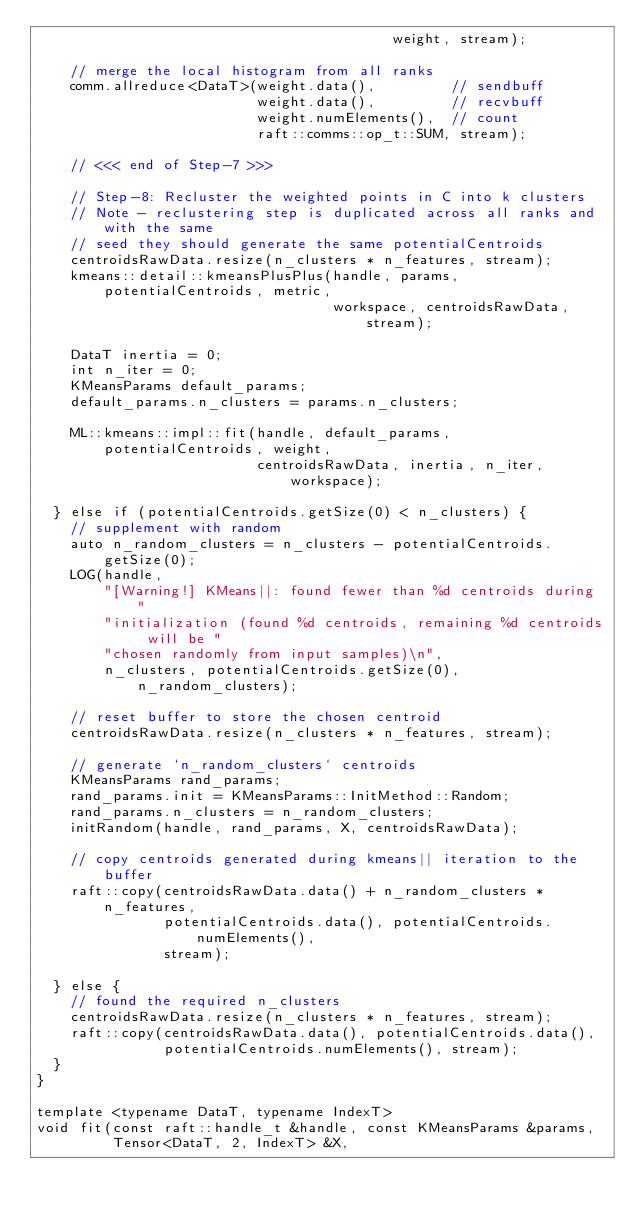Convert code to text. <code><loc_0><loc_0><loc_500><loc_500><_Cuda_>                                          weight, stream);

    // merge the local histogram from all ranks
    comm.allreduce<DataT>(weight.data(),         // sendbuff
                          weight.data(),         // recvbuff
                          weight.numElements(),  // count
                          raft::comms::op_t::SUM, stream);

    // <<< end of Step-7 >>>

    // Step-8: Recluster the weighted points in C into k clusters
    // Note - reclustering step is duplicated across all ranks and with the same
    // seed they should generate the same potentialCentroids
    centroidsRawData.resize(n_clusters * n_features, stream);
    kmeans::detail::kmeansPlusPlus(handle, params, potentialCentroids, metric,
                                   workspace, centroidsRawData, stream);

    DataT inertia = 0;
    int n_iter = 0;
    KMeansParams default_params;
    default_params.n_clusters = params.n_clusters;

    ML::kmeans::impl::fit(handle, default_params, potentialCentroids, weight,
                          centroidsRawData, inertia, n_iter, workspace);

  } else if (potentialCentroids.getSize(0) < n_clusters) {
    // supplement with random
    auto n_random_clusters = n_clusters - potentialCentroids.getSize(0);
    LOG(handle,
        "[Warning!] KMeans||: found fewer than %d centroids during "
        "initialization (found %d centroids, remaining %d centroids will be "
        "chosen randomly from input samples)\n",
        n_clusters, potentialCentroids.getSize(0), n_random_clusters);

    // reset buffer to store the chosen centroid
    centroidsRawData.resize(n_clusters * n_features, stream);

    // generate `n_random_clusters` centroids
    KMeansParams rand_params;
    rand_params.init = KMeansParams::InitMethod::Random;
    rand_params.n_clusters = n_random_clusters;
    initRandom(handle, rand_params, X, centroidsRawData);

    // copy centroids generated during kmeans|| iteration to the buffer
    raft::copy(centroidsRawData.data() + n_random_clusters * n_features,
               potentialCentroids.data(), potentialCentroids.numElements(),
               stream);

  } else {
    // found the required n_clusters
    centroidsRawData.resize(n_clusters * n_features, stream);
    raft::copy(centroidsRawData.data(), potentialCentroids.data(),
               potentialCentroids.numElements(), stream);
  }
}

template <typename DataT, typename IndexT>
void fit(const raft::handle_t &handle, const KMeansParams &params,
         Tensor<DataT, 2, IndexT> &X,</code> 